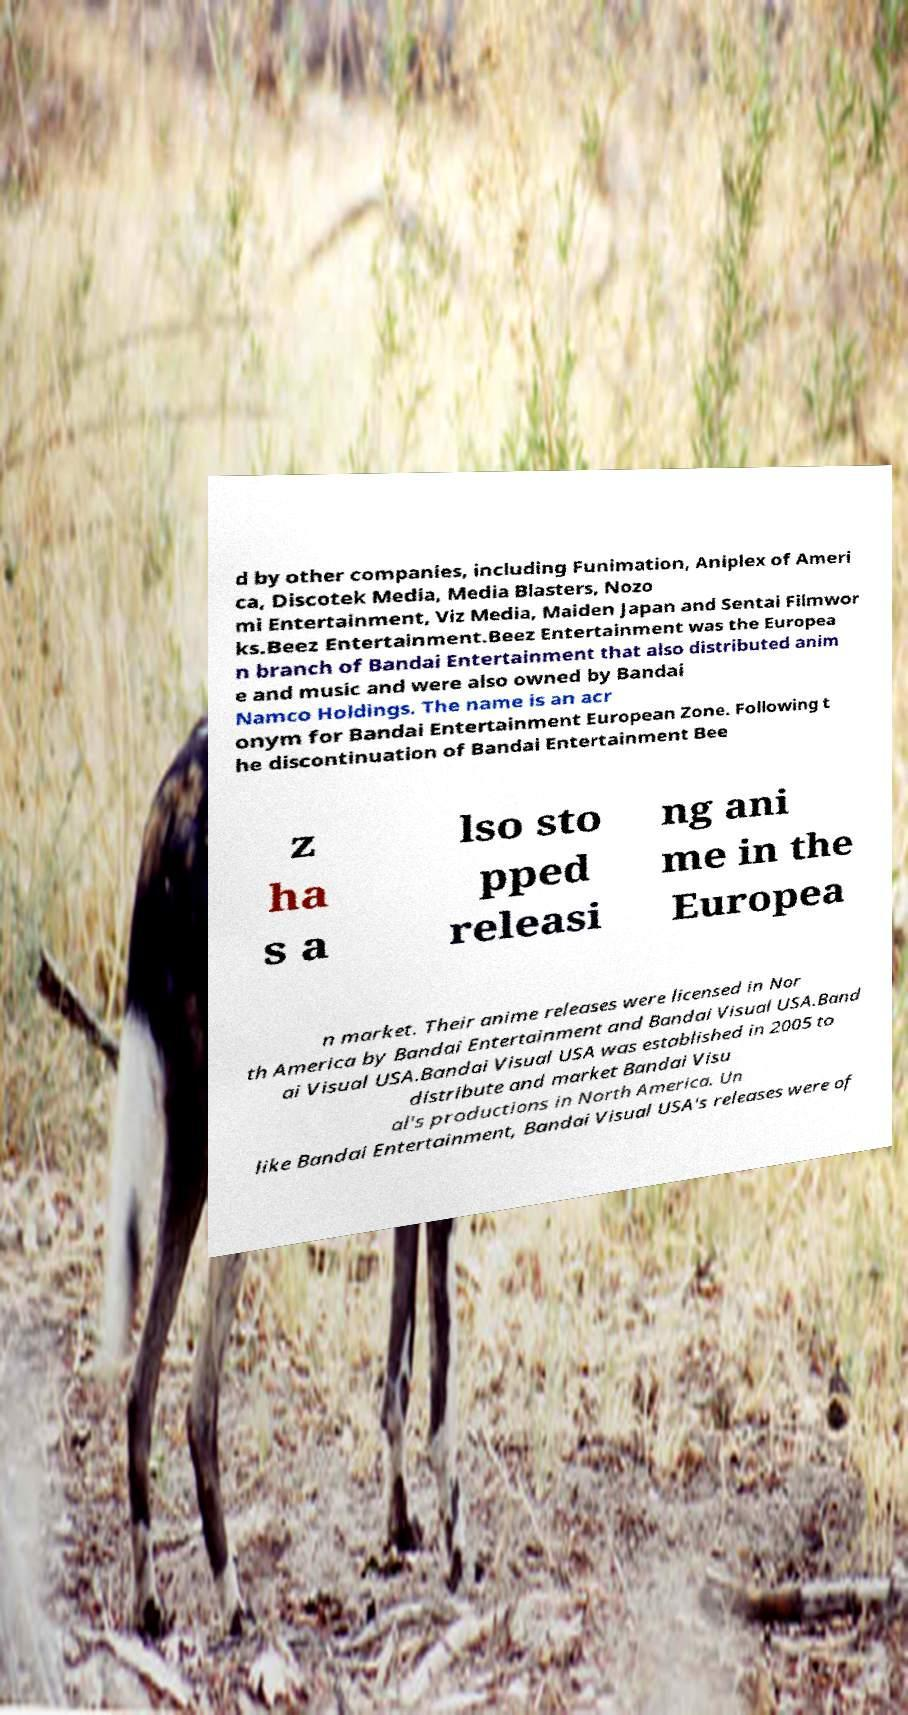Please read and relay the text visible in this image. What does it say? d by other companies, including Funimation, Aniplex of Ameri ca, Discotek Media, Media Blasters, Nozo mi Entertainment, Viz Media, Maiden Japan and Sentai Filmwor ks.Beez Entertainment.Beez Entertainment was the Europea n branch of Bandai Entertainment that also distributed anim e and music and were also owned by Bandai Namco Holdings. The name is an acr onym for Bandai Entertainment European Zone. Following t he discontinuation of Bandai Entertainment Bee z ha s a lso sto pped releasi ng ani me in the Europea n market. Their anime releases were licensed in Nor th America by Bandai Entertainment and Bandai Visual USA.Band ai Visual USA.Bandai Visual USA was established in 2005 to distribute and market Bandai Visu al's productions in North America. Un like Bandai Entertainment, Bandai Visual USA's releases were of 